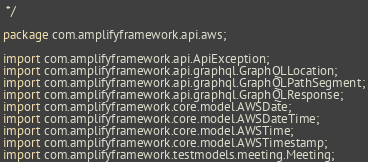<code> <loc_0><loc_0><loc_500><loc_500><_Java_> */

package com.amplifyframework.api.aws;

import com.amplifyframework.api.ApiException;
import com.amplifyframework.api.graphql.GraphQLLocation;
import com.amplifyframework.api.graphql.GraphQLPathSegment;
import com.amplifyframework.api.graphql.GraphQLResponse;
import com.amplifyframework.core.model.AWSDate;
import com.amplifyframework.core.model.AWSDateTime;
import com.amplifyframework.core.model.AWSTime;
import com.amplifyframework.core.model.AWSTimestamp;
import com.amplifyframework.testmodels.meeting.Meeting;</code> 